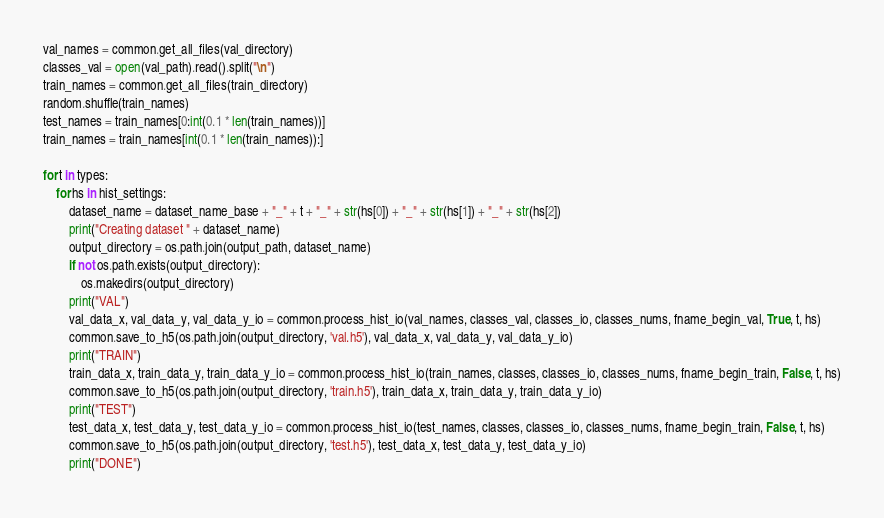<code> <loc_0><loc_0><loc_500><loc_500><_Python_>val_names = common.get_all_files(val_directory)
classes_val = open(val_path).read().split("\n")
train_names = common.get_all_files(train_directory)
random.shuffle(train_names)
test_names = train_names[0:int(0.1 * len(train_names))]
train_names = train_names[int(0.1 * len(train_names)):]

for t in types:
    for hs in hist_settings:
        dataset_name = dataset_name_base + "_" + t + "_" + str(hs[0]) + "_" + str(hs[1]) + "_" + str(hs[2])
        print("Creating dataset " + dataset_name)
        output_directory = os.path.join(output_path, dataset_name)
        if not os.path.exists(output_directory):
            os.makedirs(output_directory)
        print("VAL")
        val_data_x, val_data_y, val_data_y_io = common.process_hist_io(val_names, classes_val, classes_io, classes_nums, fname_begin_val, True, t, hs)
        common.save_to_h5(os.path.join(output_directory, 'val.h5'), val_data_x, val_data_y, val_data_y_io)
        print("TRAIN")
        train_data_x, train_data_y, train_data_y_io = common.process_hist_io(train_names, classes, classes_io, classes_nums, fname_begin_train, False, t, hs)
        common.save_to_h5(os.path.join(output_directory, 'train.h5'), train_data_x, train_data_y, train_data_y_io)
        print("TEST")
        test_data_x, test_data_y, test_data_y_io = common.process_hist_io(test_names, classes, classes_io, classes_nums, fname_begin_train, False, t, hs)
        common.save_to_h5(os.path.join(output_directory, 'test.h5'), test_data_x, test_data_y, test_data_y_io)
        print("DONE")
</code> 